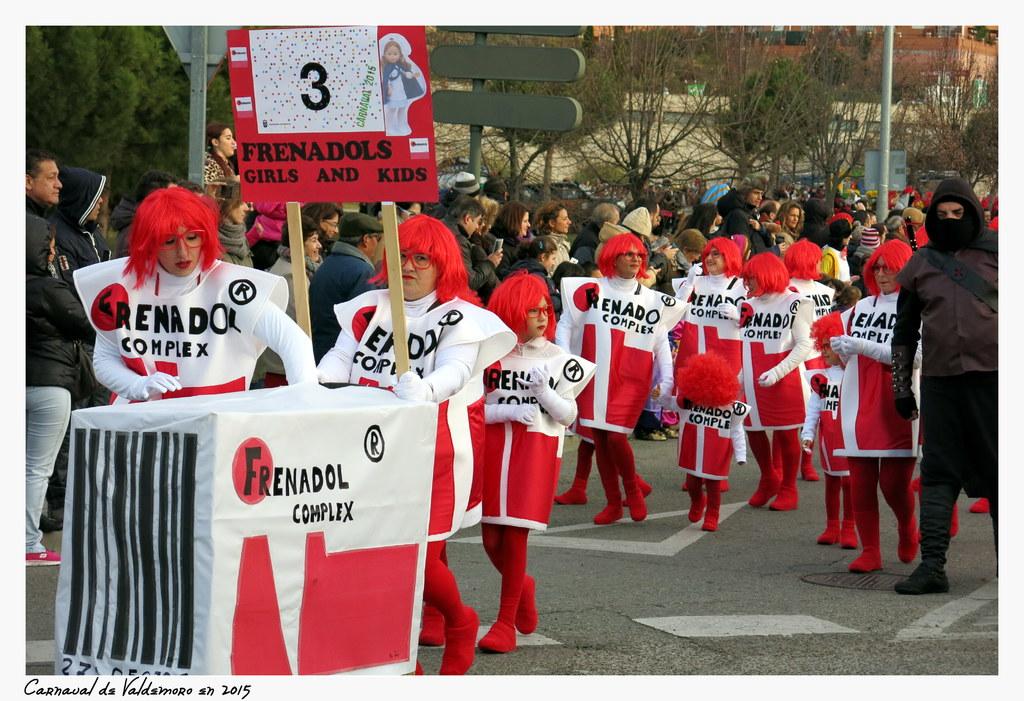What is written on the large sign being held by the girl?
Your answer should be very brief. Frenadols girls and kids. 